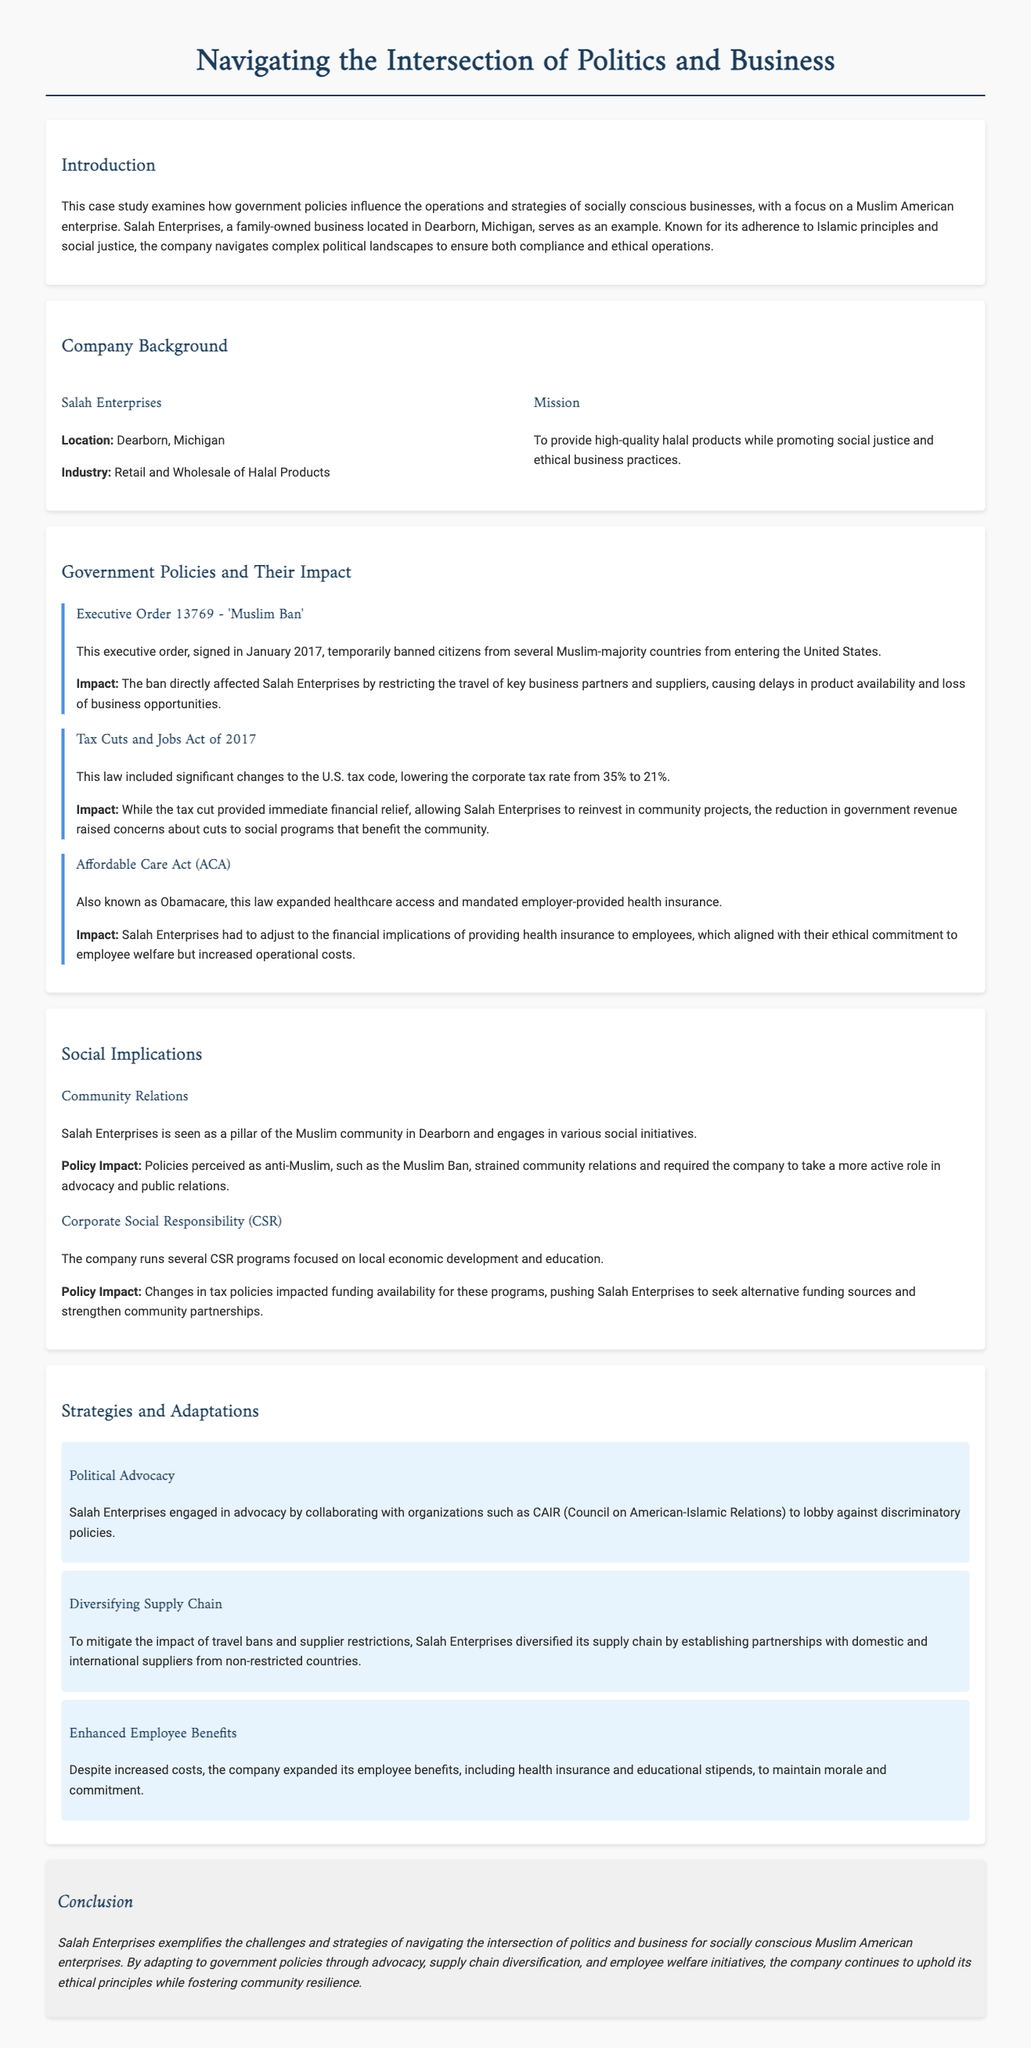What is the location of Salah Enterprises? The document states that Salah Enterprises is located in Dearborn, Michigan.
Answer: Dearborn, Michigan What does Salah Enterprises primarily sell? The company is involved in the retail and wholesale of halal products.
Answer: Halal products What was the direct impact of the Muslim Ban on Salah Enterprises? The ban restricted the travel of key business partners and suppliers, which caused delays in product availability.
Answer: Delays in product availability What significant law reduced the corporate tax rate in 2017? The document refers to the Tax Cuts and Jobs Act of 2017, which lowered the corporate tax rate.
Answer: Tax Cuts and Jobs Act of 2017 Which organization did Salah Enterprises collaborate with for political advocacy? The case study mentions collaboration with CAIR (Council on American-Islamic Relations) for political advocacy efforts.
Answer: CAIR What type of programs does Salah Enterprises run under Corporate Social Responsibility? The company runs CSR programs focused on local economic development and education.
Answer: Local economic development and education How did Salah Enterprises adapt its supply chain in response to travel bans? The company diversified its supply chain by establishing partnerships with suppliers from non-restricted countries.
Answer: Diversified its supply chain What ethical commitment did Salah Enterprises uphold by providing health insurance? The company had to provide health insurance to employees in line with its commitment to employee welfare.
Answer: Employee welfare What is the conclusion about how Salah Enterprises navigates politics and business? The conclusion states that Salah Enterprises exemplifies the challenges and strategies in navigating the intersection of politics and business.
Answer: Challenges and strategies in navigating politics and business 